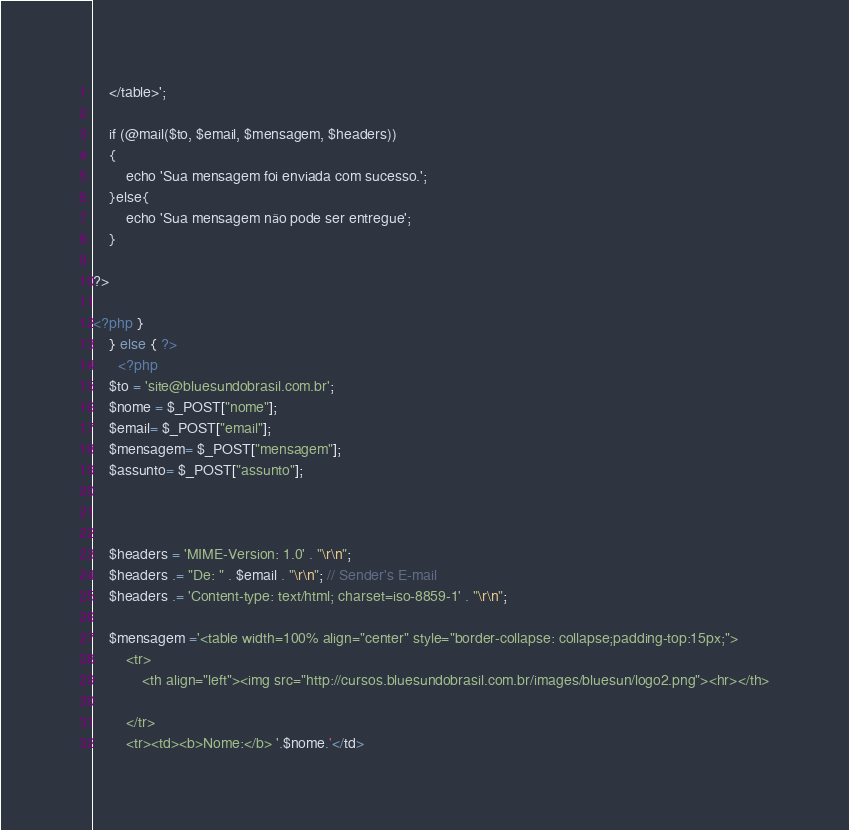<code> <loc_0><loc_0><loc_500><loc_500><_PHP_>    </table>';

    if (@mail($to, $email, $mensagem, $headers))
    {
        echo 'Sua mensagem foi enviada com sucesso.';
    }else{
        echo 'Sua mensagem não pode ser entregue';
    }

?>

<?php }
    } else { ?>
      <?php
    $to = 'site@bluesundobrasil.com.br';
    $nome = $_POST["nome"];
    $email= $_POST["email"];
    $mensagem= $_POST["mensagem"];
    $assunto= $_POST["assunto"];
    


    $headers = 'MIME-Version: 1.0' . "\r\n";
    $headers .= "De: " . $email . "\r\n"; // Sender's E-mail
    $headers .= 'Content-type: text/html; charset=iso-8859-1' . "\r\n";

    $mensagem ='<table width=100% align="center" style="border-collapse: collapse;padding-top:15px;">
        <tr>
            <th align="left"><img src="http://cursos.bluesundobrasil.com.br/images/bluesun/logo2.png"><hr></th>
            
        </tr>
        <tr><td><b>Nome:</b> '.$nome.'</td></code> 